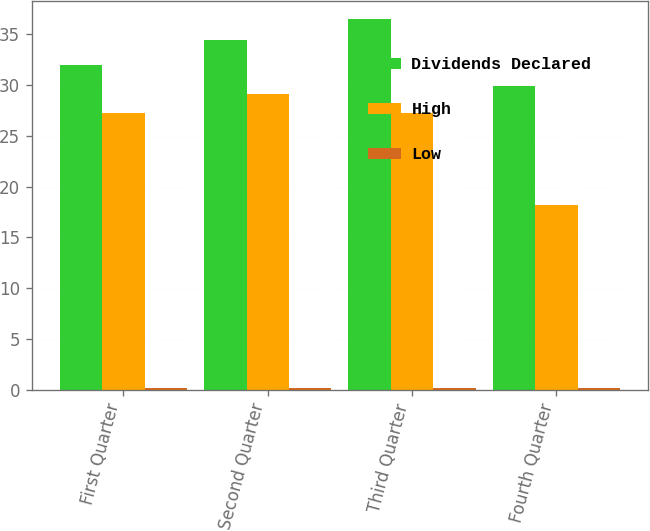Convert chart to OTSL. <chart><loc_0><loc_0><loc_500><loc_500><stacked_bar_chart><ecel><fcel>First Quarter<fcel>Second Quarter<fcel>Third Quarter<fcel>Fourth Quarter<nl><fcel>Dividends Declared<fcel>32<fcel>34.44<fcel>36.52<fcel>29.96<nl><fcel>High<fcel>27.3<fcel>29.09<fcel>27.29<fcel>18.25<nl><fcel>Low<fcel>0.17<fcel>0.17<fcel>0.19<fcel>0.19<nl></chart> 